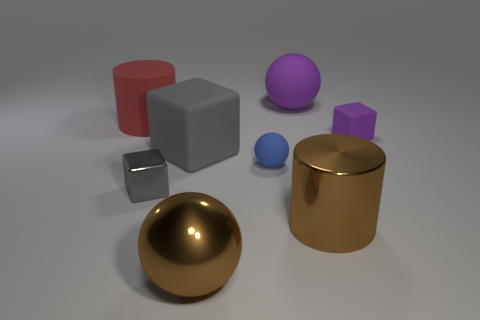What is the size of the object that is the same color as the large metallic sphere?
Make the answer very short. Large. Are there the same number of big objects that are in front of the large rubber sphere and big objects that are on the right side of the shiny cube?
Your answer should be very brief. Yes. Is the material of the tiny blue sphere the same as the brown ball?
Provide a succinct answer. No. Are there any big rubber objects behind the large cylinder that is on the left side of the big rubber sphere?
Offer a very short reply. Yes. Are there any purple objects of the same shape as the small blue thing?
Your answer should be very brief. Yes. Is the metal sphere the same color as the large metal cylinder?
Keep it short and to the point. Yes. There is a object that is behind the matte object on the left side of the tiny metal object; what is its material?
Make the answer very short. Rubber. The brown sphere has what size?
Provide a succinct answer. Large. There is a purple cube that is the same material as the small sphere; what size is it?
Provide a short and direct response. Small. There is a cylinder that is in front of the red matte object; is it the same size as the red matte cylinder?
Provide a short and direct response. Yes. 